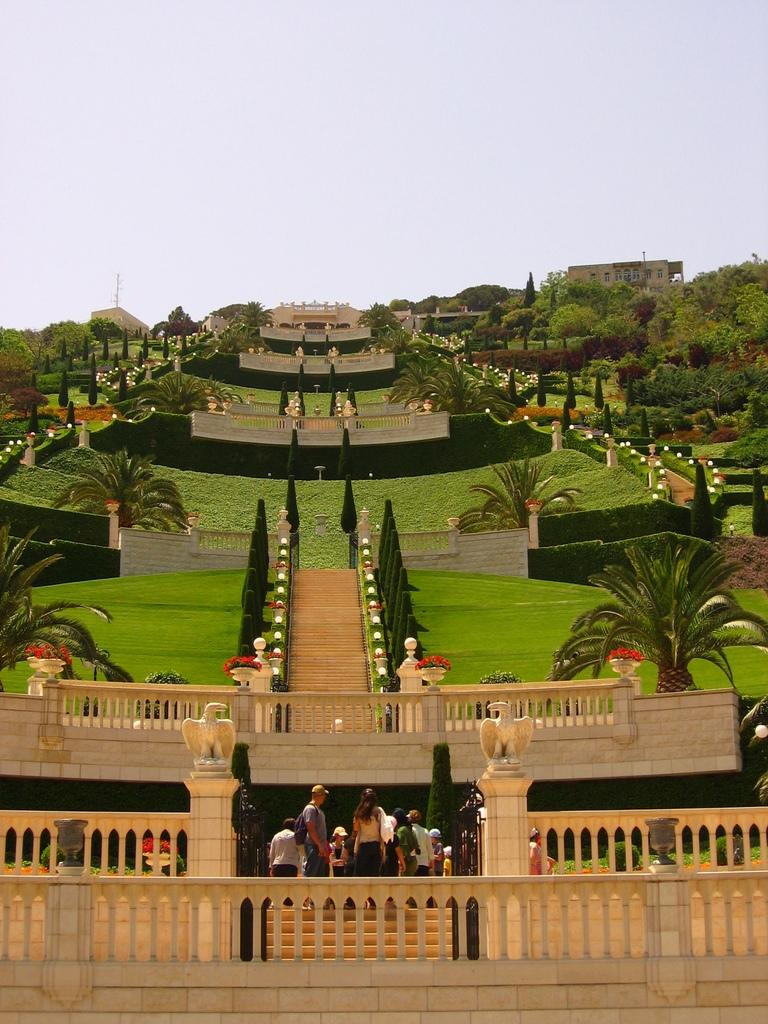What can be seen in the image involving people and staircases? There are people standing near staircases in the image. How many staircases are visible in the image? There are additional staircases visible in the image. What can be seen in the background of the image? There are walls, trees, and grass visible in the background of the image. What type of drink is being served to the cats in the image? There are no cats or drinks present in the image. Can you describe the flight of the birds in the image? There are no birds or flights depicted in the image. 